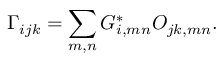<formula> <loc_0><loc_0><loc_500><loc_500>\Gamma _ { i j k } = \sum _ { m , n } G _ { i , m n } ^ { * } O _ { j k , m n } .</formula> 